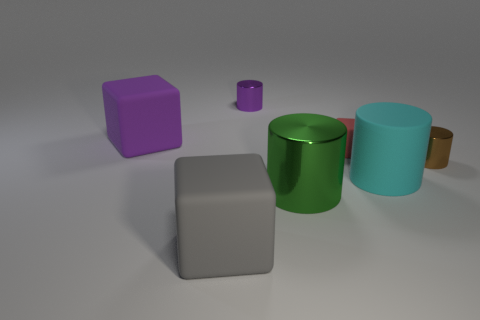Do the big metallic thing to the left of the cyan object and the large cyan rubber object have the same shape?
Keep it short and to the point. Yes. Is the big cyan rubber thing the same shape as the purple rubber thing?
Your answer should be very brief. No. How many rubber things are large green cylinders or big cylinders?
Provide a succinct answer. 1. Do the gray rubber block and the purple metallic cylinder have the same size?
Your response must be concise. No. How many things are small gray metallic blocks or cylinders that are to the left of the brown cylinder?
Provide a short and direct response. 3. There is a gray thing that is the same size as the green object; what material is it?
Provide a succinct answer. Rubber. What material is the cylinder that is to the left of the brown metallic thing and behind the cyan cylinder?
Your answer should be very brief. Metal. Is there a cylinder that is in front of the metal cylinder that is behind the brown metal cylinder?
Give a very brief answer. Yes. There is a rubber block that is both to the right of the big purple cube and left of the small purple metal thing; what size is it?
Offer a terse response. Large. What number of brown things are big cylinders or large metal cylinders?
Your response must be concise. 0. 